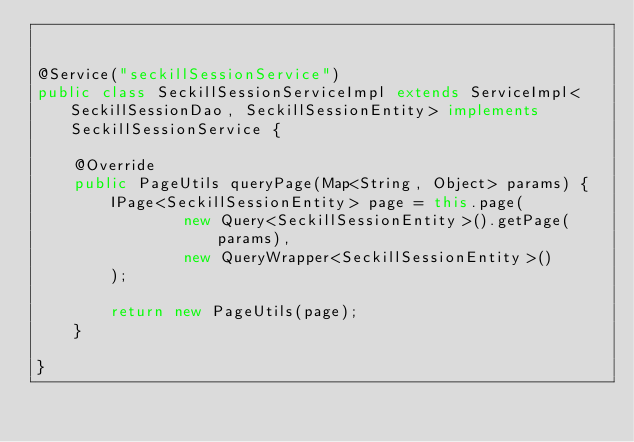<code> <loc_0><loc_0><loc_500><loc_500><_Java_>

@Service("seckillSessionService")
public class SeckillSessionServiceImpl extends ServiceImpl<SeckillSessionDao, SeckillSessionEntity> implements SeckillSessionService {

    @Override
    public PageUtils queryPage(Map<String, Object> params) {
        IPage<SeckillSessionEntity> page = this.page(
                new Query<SeckillSessionEntity>().getPage(params),
                new QueryWrapper<SeckillSessionEntity>()
        );

        return new PageUtils(page);
    }

}</code> 